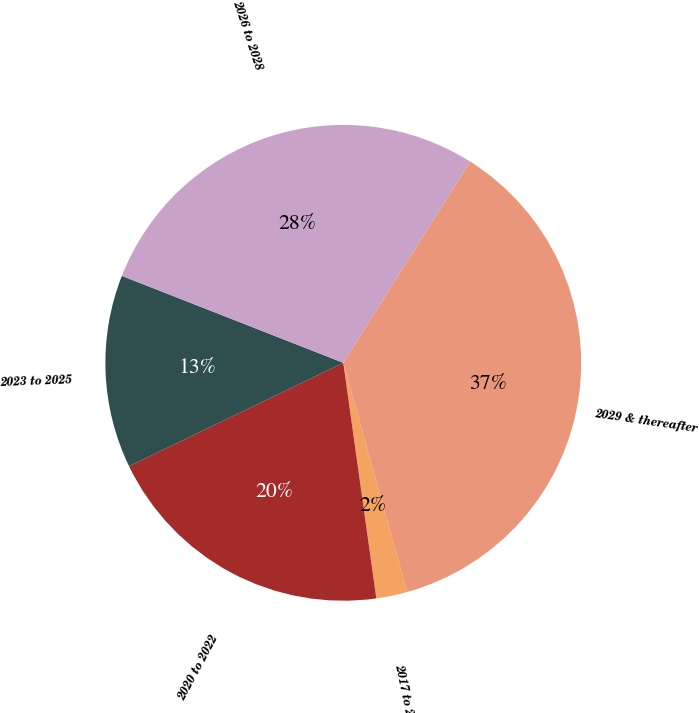Convert chart to OTSL. <chart><loc_0><loc_0><loc_500><loc_500><pie_chart><fcel>2017 to 2019<fcel>2020 to 2022<fcel>2023 to 2025<fcel>2026 to 2028<fcel>2029 & thereafter<nl><fcel>2.11%<fcel>20.06%<fcel>13.11%<fcel>28.0%<fcel>36.72%<nl></chart> 